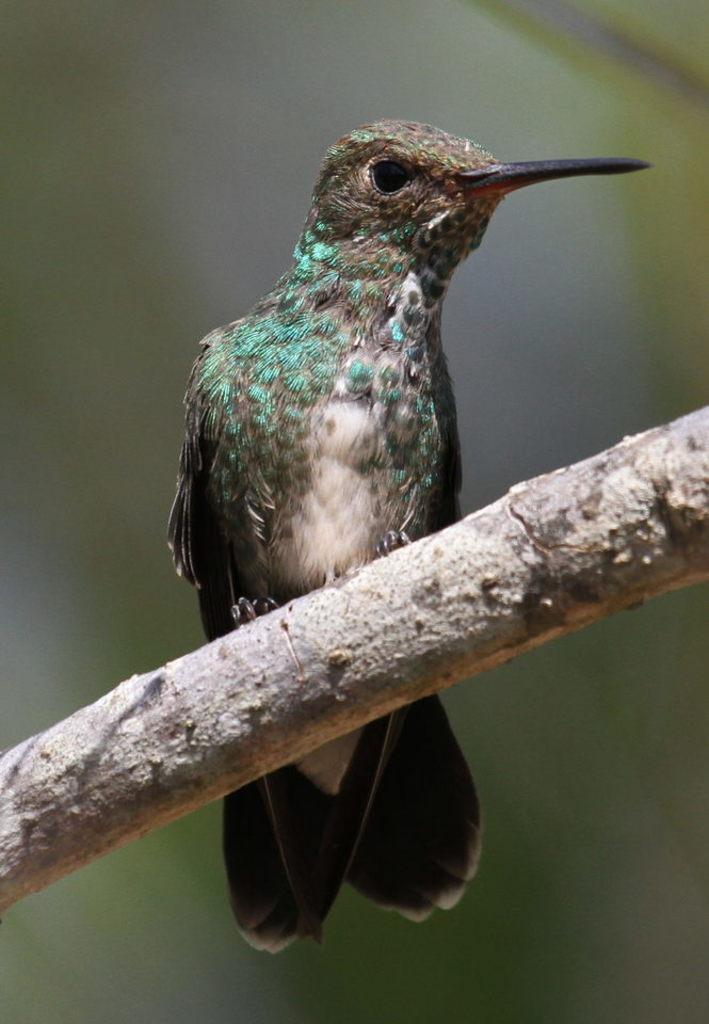Can you describe this image briefly? In this picture I can see a wooden stick, on which there is a bird which is of white, brown and blue color. I see that it is blurred in the background. 